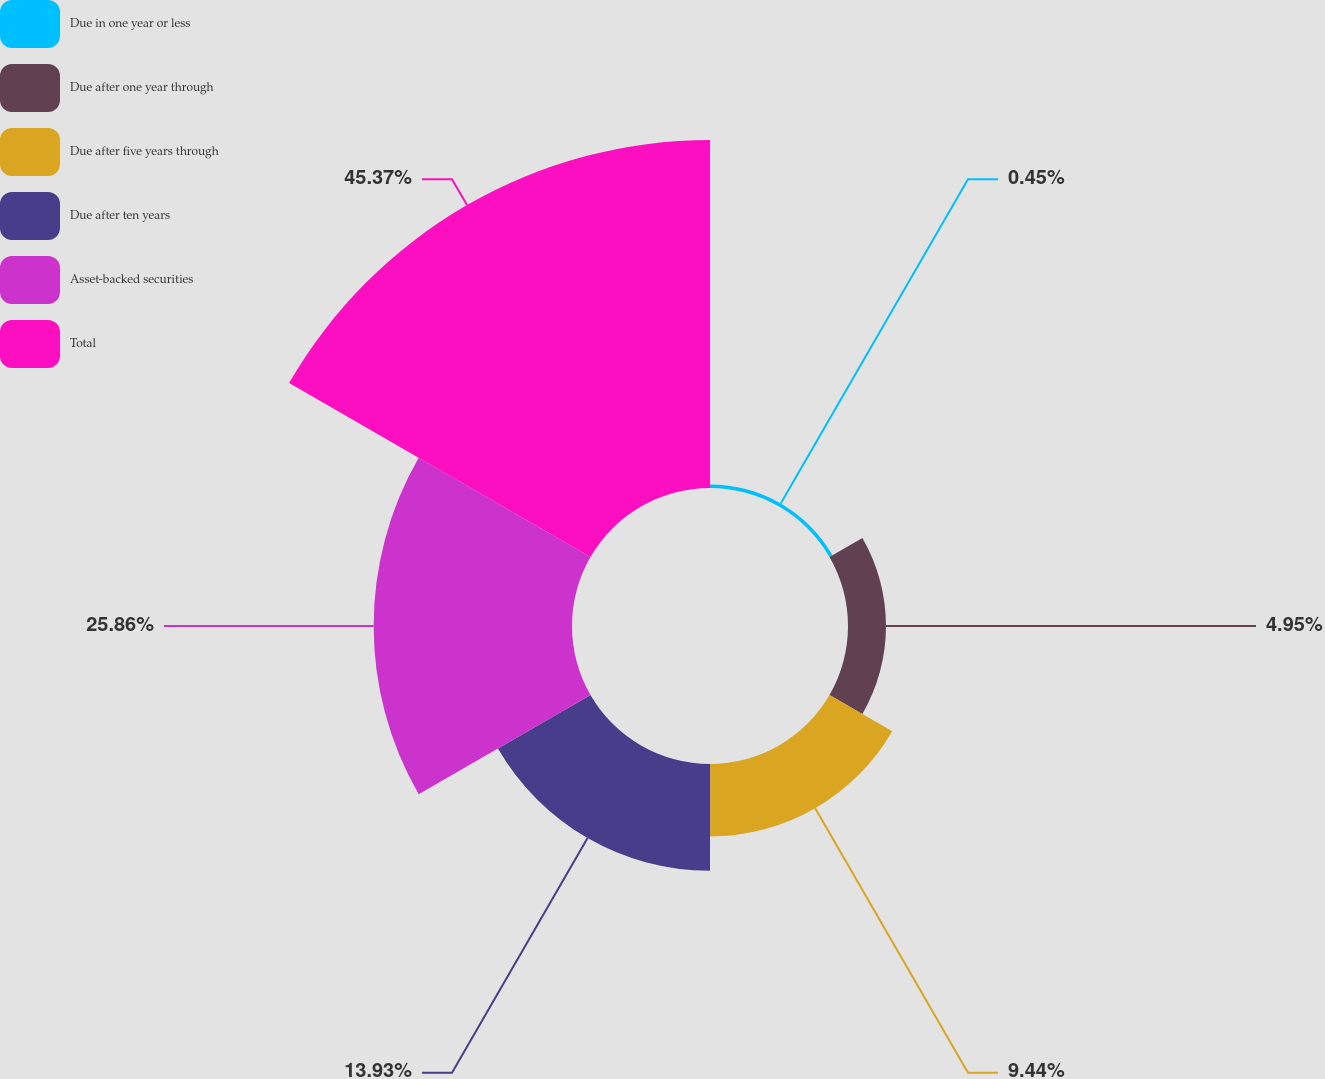Convert chart. <chart><loc_0><loc_0><loc_500><loc_500><pie_chart><fcel>Due in one year or less<fcel>Due after one year through<fcel>Due after five years through<fcel>Due after ten years<fcel>Asset-backed securities<fcel>Total<nl><fcel>0.45%<fcel>4.95%<fcel>9.44%<fcel>13.93%<fcel>25.86%<fcel>45.37%<nl></chart> 